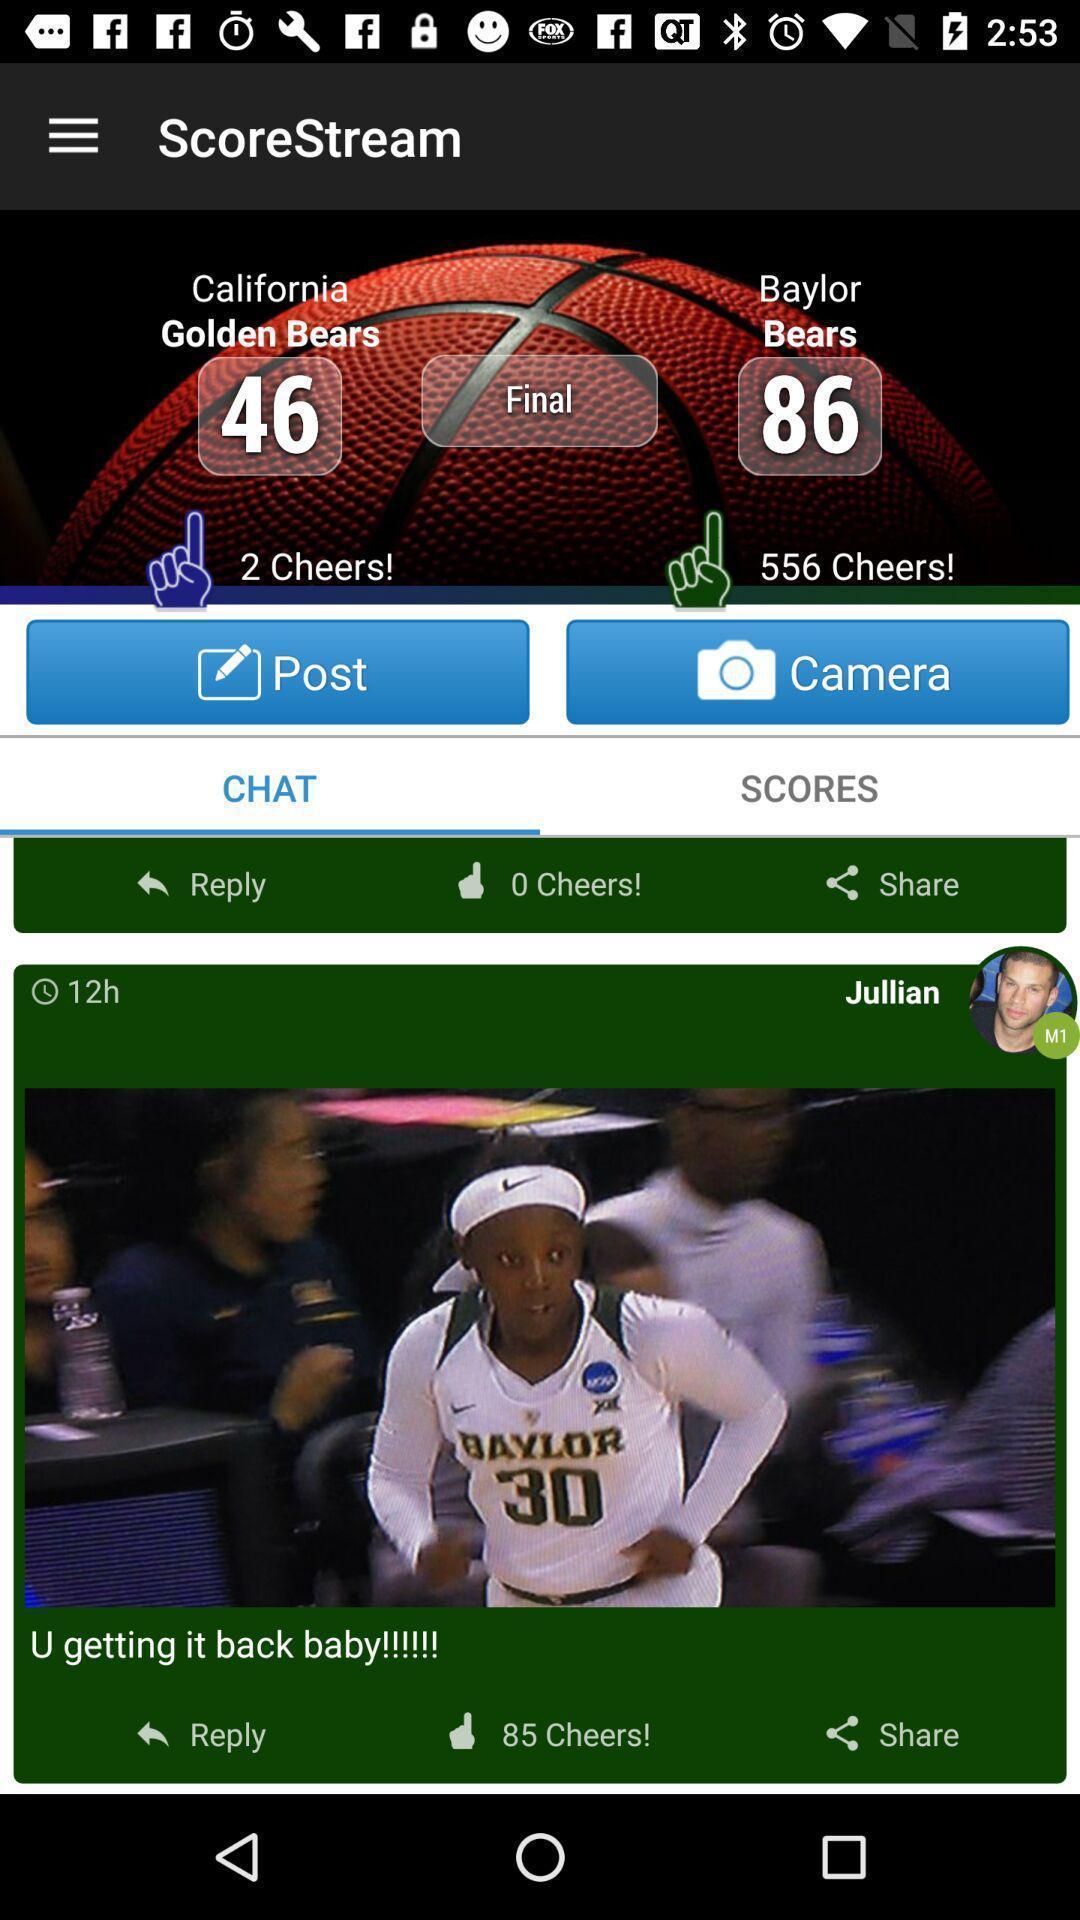Describe this image in words. Sport app displaying team scores and other options. 